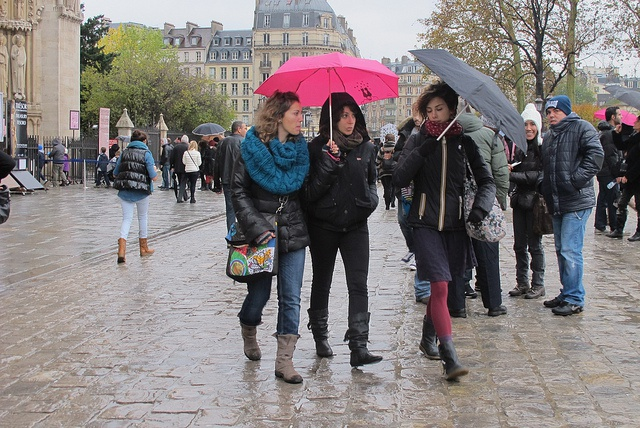Describe the objects in this image and their specific colors. I can see people in tan, black, gray, blue, and darkgray tones, people in tan, black, gray, maroon, and brown tones, people in tan, black, gray, darkgray, and brown tones, people in tan, black, gray, and darkgray tones, and people in tan, black, and gray tones in this image. 